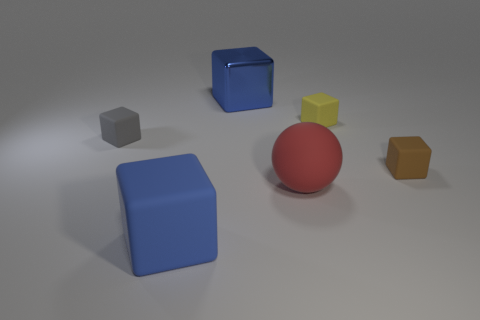What is the material of the big red sphere?
Provide a short and direct response. Rubber. Are there any small green balls?
Make the answer very short. No. There is a large cube behind the red rubber object; what is its color?
Your answer should be compact. Blue. There is a large block that is in front of the small object that is on the left side of the blue matte block; how many blue blocks are behind it?
Provide a short and direct response. 1. There is a tiny thing that is on the right side of the tiny gray cube and in front of the small yellow thing; what material is it?
Make the answer very short. Rubber. Is the tiny brown thing made of the same material as the large block that is behind the red object?
Your answer should be very brief. No. Are there more blue cubes that are behind the big rubber sphere than metallic objects that are in front of the brown rubber cube?
Offer a very short reply. Yes. The large red object has what shape?
Ensure brevity in your answer.  Sphere. Are the large blue thing that is to the right of the big blue matte thing and the large blue thing in front of the tiny yellow matte cube made of the same material?
Ensure brevity in your answer.  No. What shape is the blue thing that is behind the tiny gray object?
Offer a terse response. Cube. 